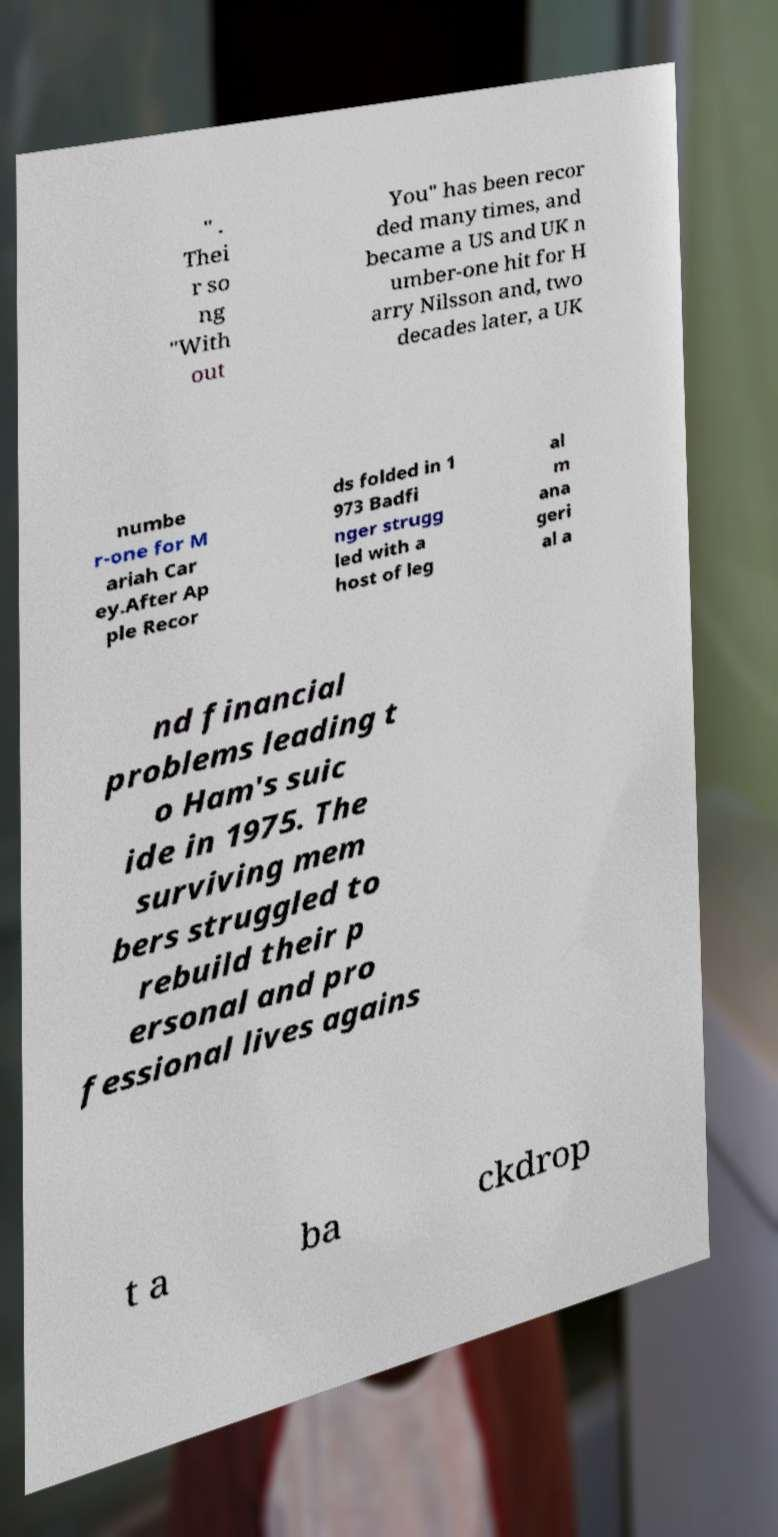Please identify and transcribe the text found in this image. " . Thei r so ng "With out You" has been recor ded many times, and became a US and UK n umber-one hit for H arry Nilsson and, two decades later, a UK numbe r-one for M ariah Car ey.After Ap ple Recor ds folded in 1 973 Badfi nger strugg led with a host of leg al m ana geri al a nd financial problems leading t o Ham's suic ide in 1975. The surviving mem bers struggled to rebuild their p ersonal and pro fessional lives agains t a ba ckdrop 